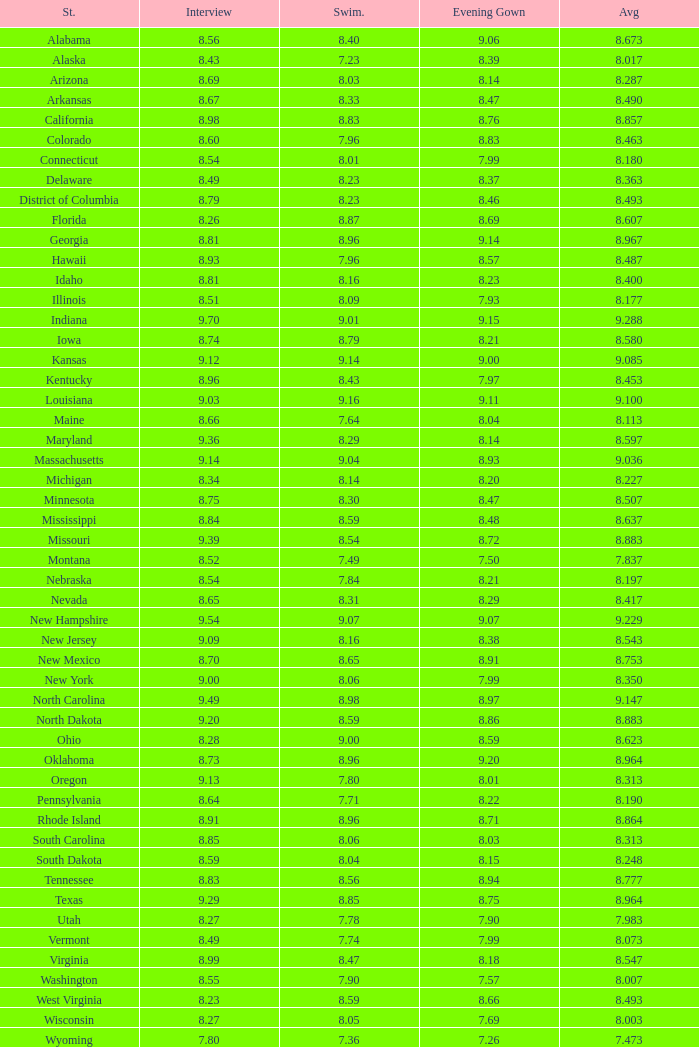Name the total number of swimsuits for evening gowns less than 8.21 and average of 8.453 with interview less than 9.09 1.0. 